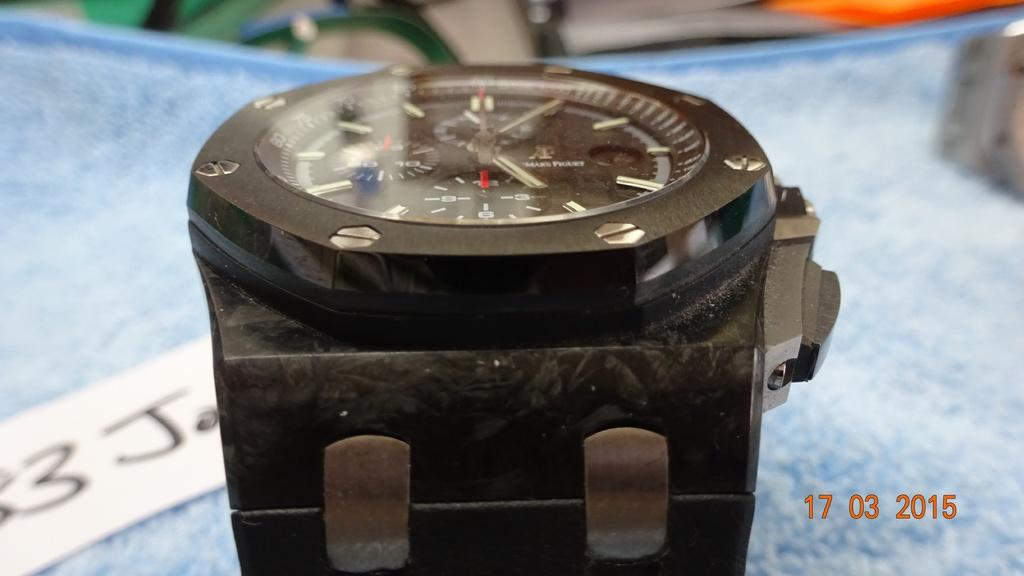<image>
Relay a brief, clear account of the picture shown. A brown watch is on a blue table and the year 2015 is printed out to the side. 